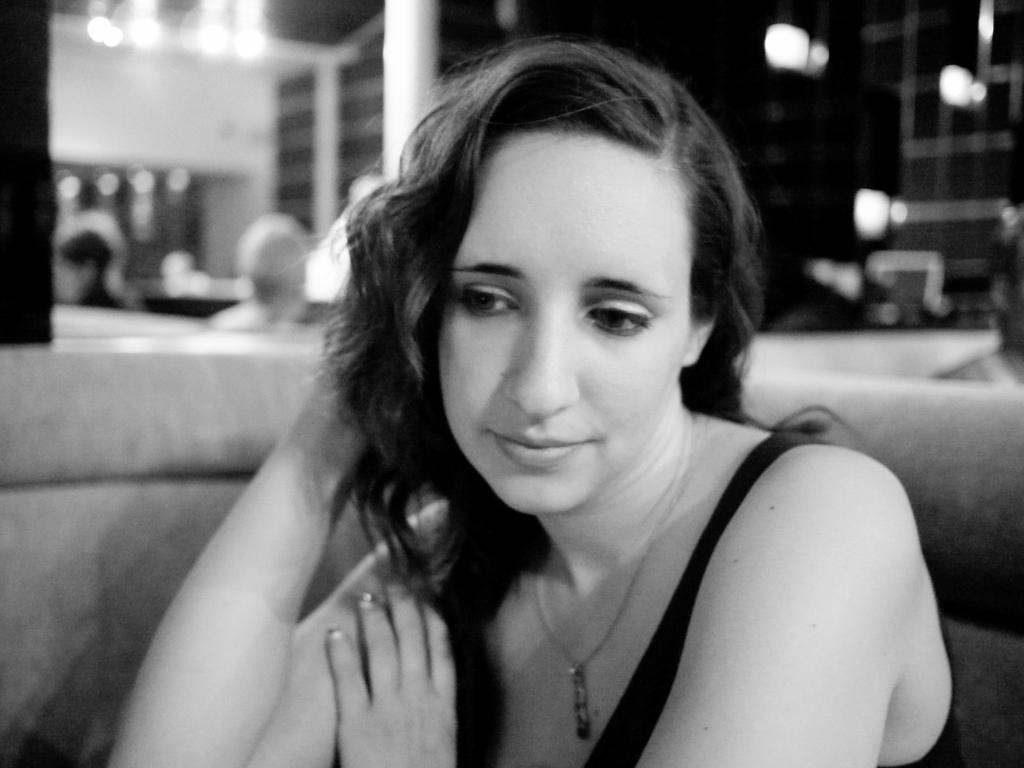What is the color scheme of the image? The image is black and white. What is the person in the image doing? The person is sitting on a sofa in the image. What can be seen behind the person? There are lights visible behind the person. What is in the background of the image? There is a wall in the background of the image. What type of fiction is the person reading in the image? There is no book or any indication of reading in the image, so it cannot be determined if the person is reading fiction. 